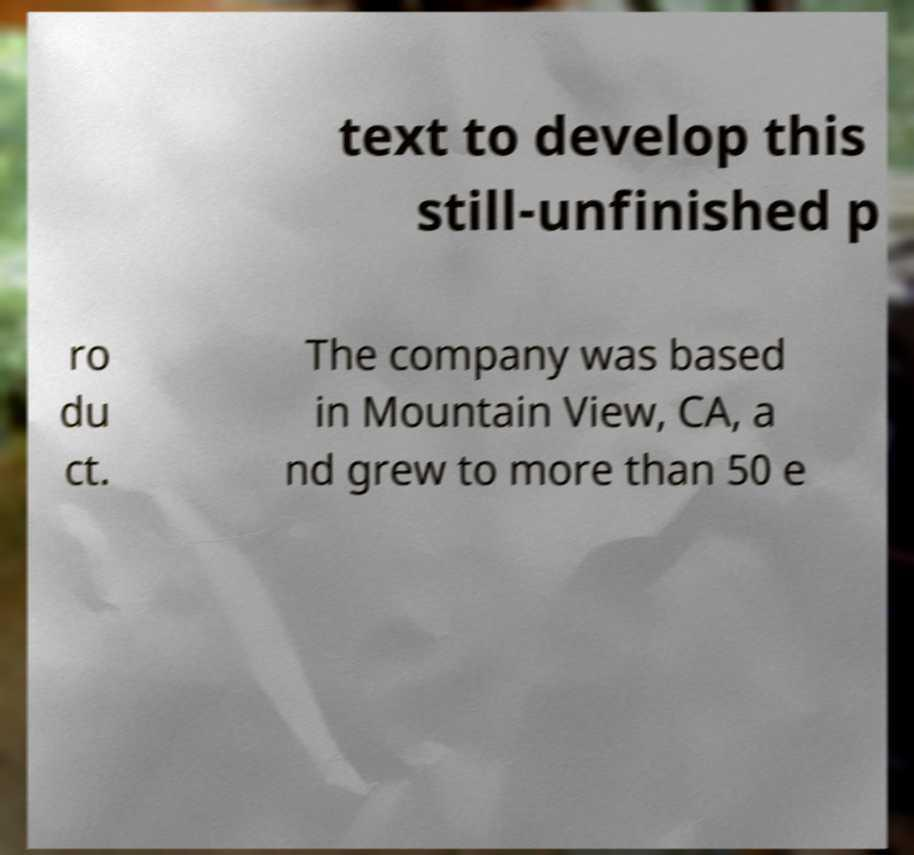Can you read and provide the text displayed in the image?This photo seems to have some interesting text. Can you extract and type it out for me? text to develop this still-unfinished p ro du ct. The company was based in Mountain View, CA, a nd grew to more than 50 e 